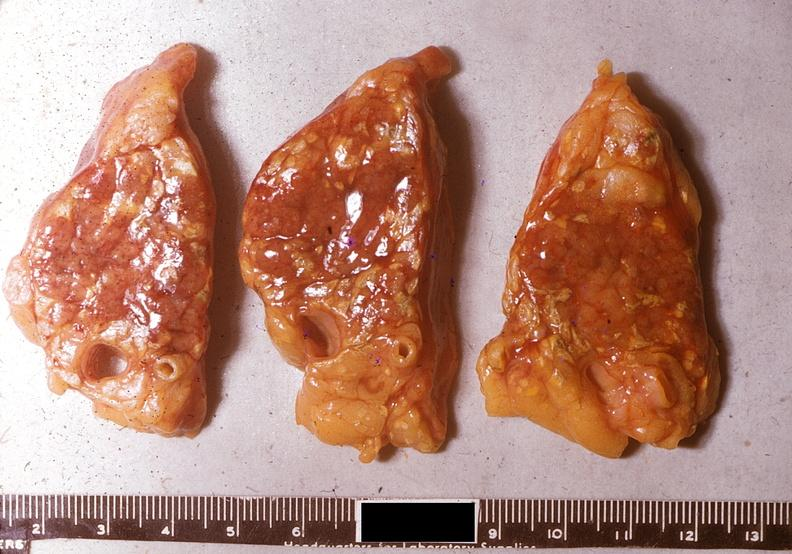does this frontal section micronodular photo show acute pancreatitis?
Answer the question using a single word or phrase. No 